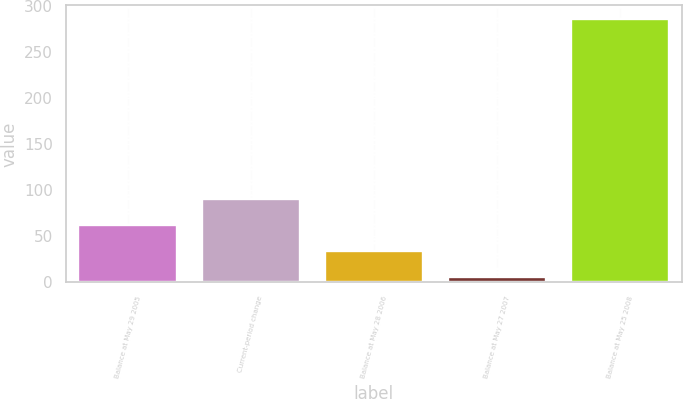Convert chart. <chart><loc_0><loc_0><loc_500><loc_500><bar_chart><fcel>Balance at May 29 2005<fcel>Current-period change<fcel>Balance at May 28 2006<fcel>Balance at May 27 2007<fcel>Balance at May 25 2008<nl><fcel>62.02<fcel>90.08<fcel>33.96<fcel>5.9<fcel>286.5<nl></chart> 